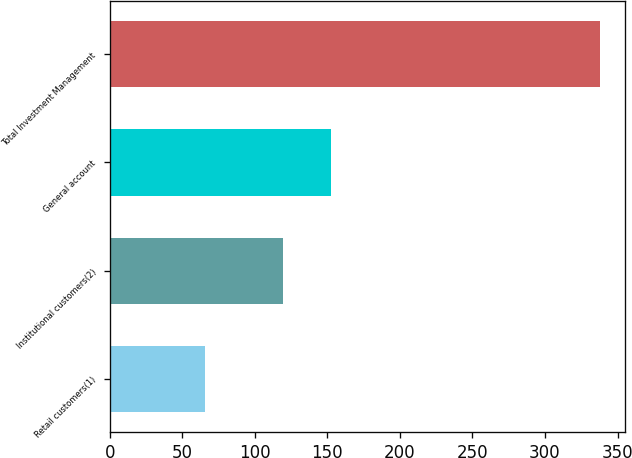Convert chart. <chart><loc_0><loc_0><loc_500><loc_500><bar_chart><fcel>Retail customers(1)<fcel>Institutional customers(2)<fcel>General account<fcel>Total Investment Management<nl><fcel>66<fcel>119.2<fcel>152.7<fcel>337.9<nl></chart> 